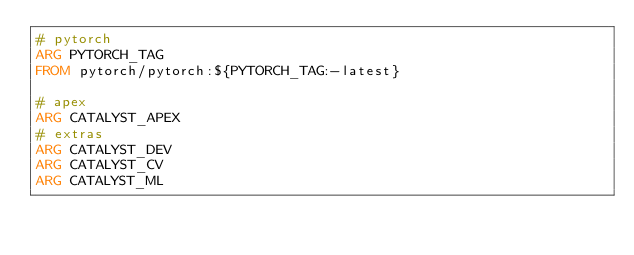<code> <loc_0><loc_0><loc_500><loc_500><_Dockerfile_># pytorch
ARG PYTORCH_TAG
FROM pytorch/pytorch:${PYTORCH_TAG:-latest}

# apex
ARG CATALYST_APEX
# extras
ARG CATALYST_DEV
ARG CATALYST_CV
ARG CATALYST_ML</code> 